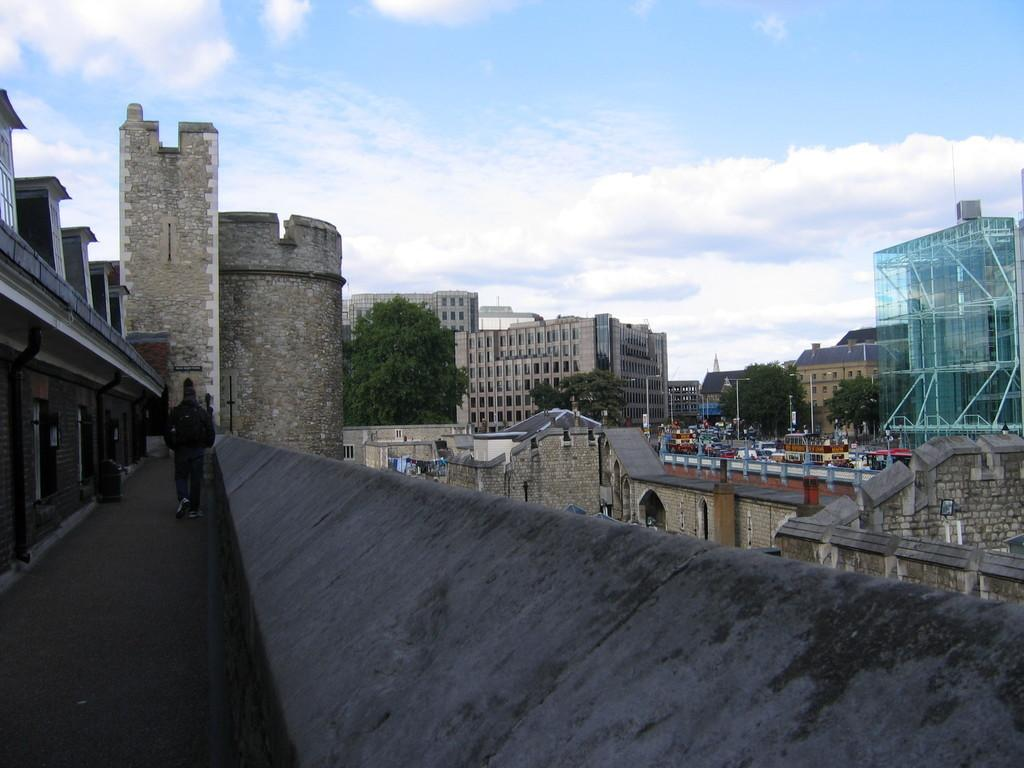What type of structures can be seen in the image? There are buildings in the image. What other natural elements are present in the image? There are trees in the image. What man-made objects can be seen in the image? There are poles, vehicles, and boards in the image. Can you describe the presence of a person in the image? There is a person walking in the image. What can be seen in the background of the image? The sky is visible in the background of the image, and there are clouds in the sky. What type of cook is depicted in the image? There is no cook present in the image. What theory is being discussed in the image? There is no discussion or reference to any theory in the image. 